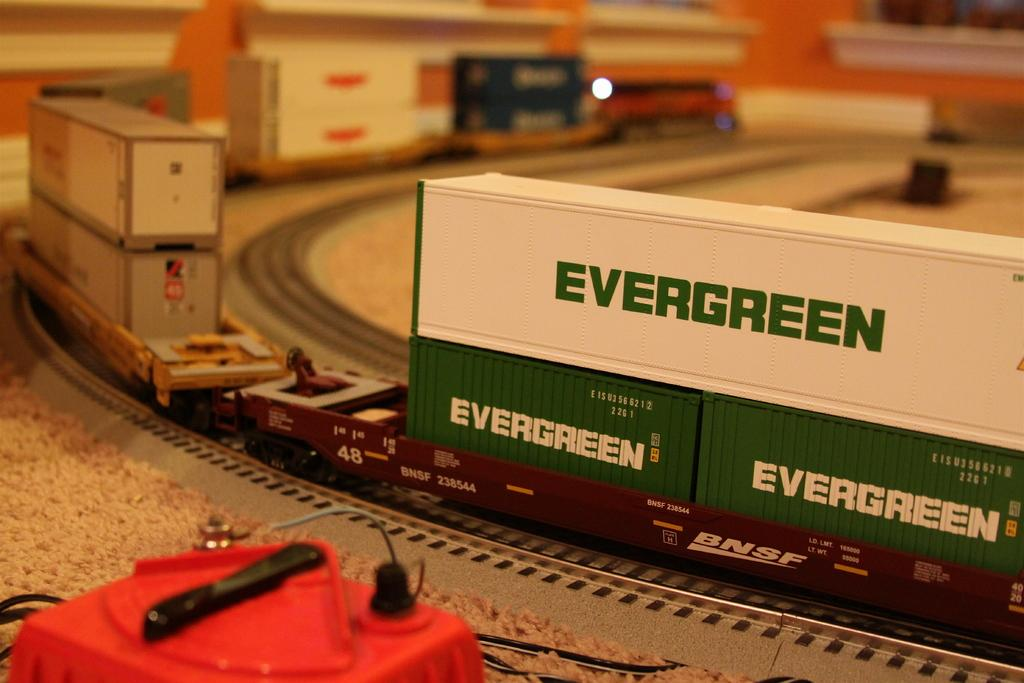<image>
Render a clear and concise summary of the photo. A model train carrying Evergreen cargo drives along a track. 